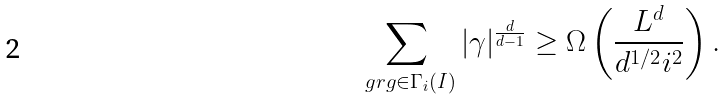<formula> <loc_0><loc_0><loc_500><loc_500>\sum _ { \ g r g \in \Gamma _ { i } ( I ) } | \gamma | ^ { \frac { d } { d - 1 } } \geq \Omega \left ( \frac { L ^ { d } } { d ^ { 1 / 2 } i ^ { 2 } } \right ) .</formula> 